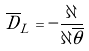<formula> <loc_0><loc_0><loc_500><loc_500>\overline { D } _ { L } = - \frac { \partial } { \partial \overline { \theta } }</formula> 